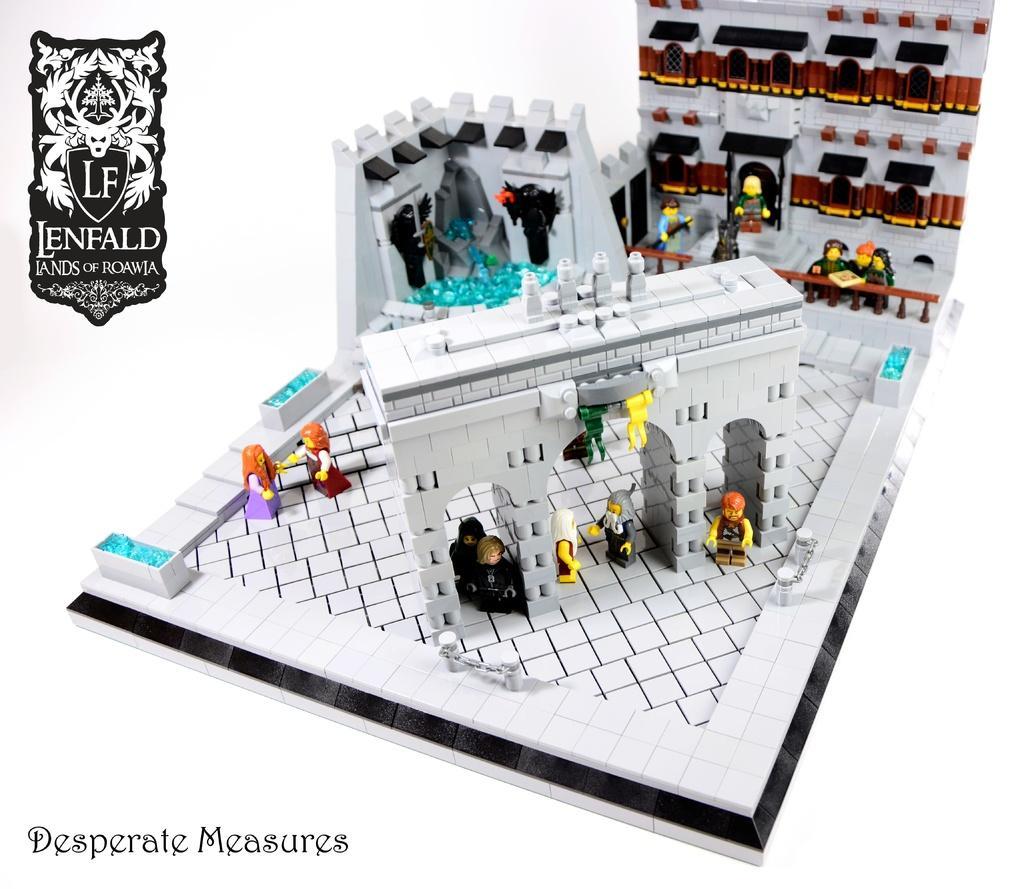Please provide a concise description of this image. In this picture we can see few toys and a building made of Lego, in the top left and bottom left we can see a logo, some text on it. 